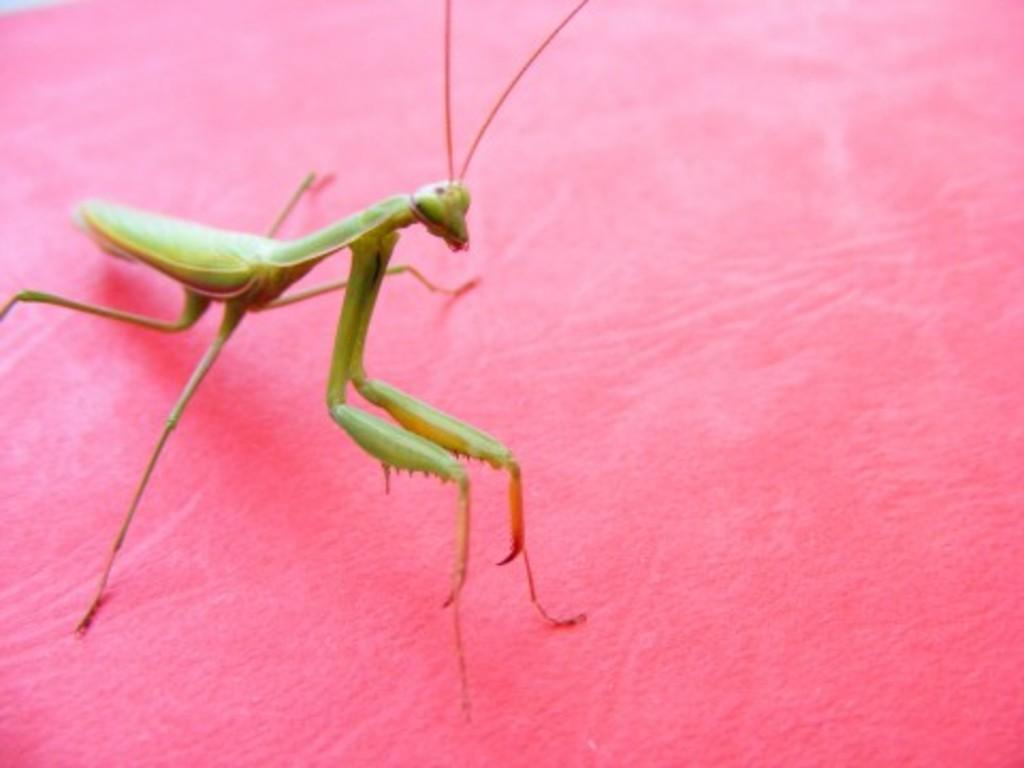What type of insect is in the image? There is a mantis in the image. What colors can be seen on the mantis? The mantis is green and orange in color. What is the color of the surface the mantis is on? The mantis is on a pink colored surface. What type of boundary can be seen in the image? There is no boundary present in the image; it features a mantis on a pink surface. Can you tell me what the mantis is thinking in the image? It is impossible to determine what the mantis is thinking from the image, as insects do not have the ability to express thoughts visually. 